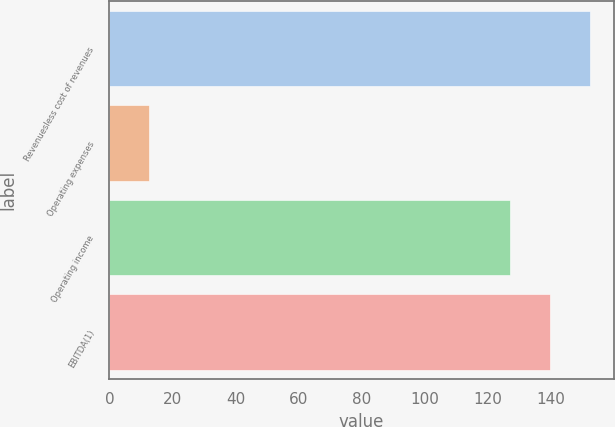Convert chart to OTSL. <chart><loc_0><loc_0><loc_500><loc_500><bar_chart><fcel>Revenuesless cost of revenues<fcel>Operating expenses<fcel>Operating income<fcel>EBITDA(1)<nl><fcel>152.16<fcel>12.7<fcel>126.8<fcel>139.48<nl></chart> 